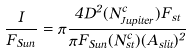Convert formula to latex. <formula><loc_0><loc_0><loc_500><loc_500>\frac { I } { F _ { S u n } } = \pi \frac { 4 D ^ { 2 } ( N ^ { c } _ { J u p i t e r } ) F _ { s t } } { \pi F _ { S u n } ( N ^ { c } _ { s t } ) ( A _ { s l i t } ) ^ { 2 } }</formula> 